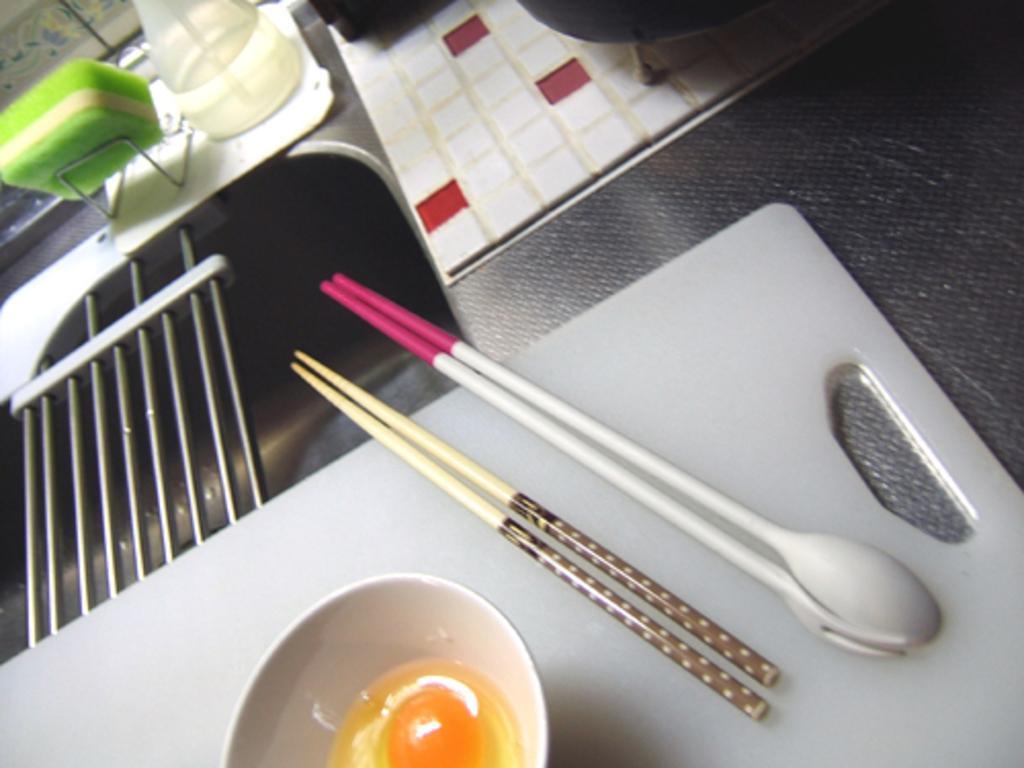In one or two sentences, can you explain what this image depicts? In this image i can see there is a spoon, wooden sticks, a bowl and other objects on it. 